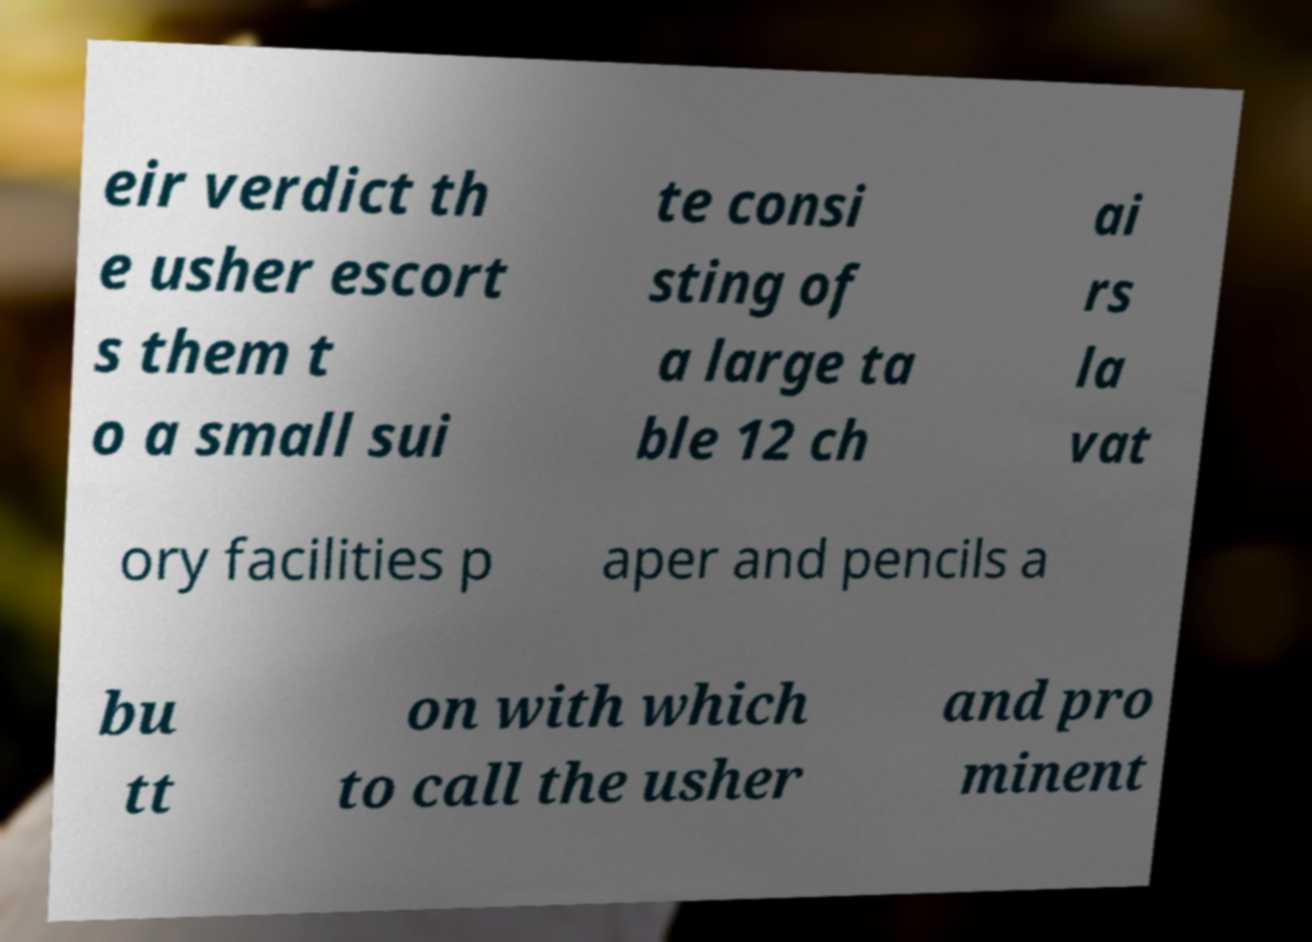What messages or text are displayed in this image? I need them in a readable, typed format. eir verdict th e usher escort s them t o a small sui te consi sting of a large ta ble 12 ch ai rs la vat ory facilities p aper and pencils a bu tt on with which to call the usher and pro minent 